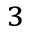<formula> <loc_0><loc_0><loc_500><loc_500>^ { 3 }</formula> 